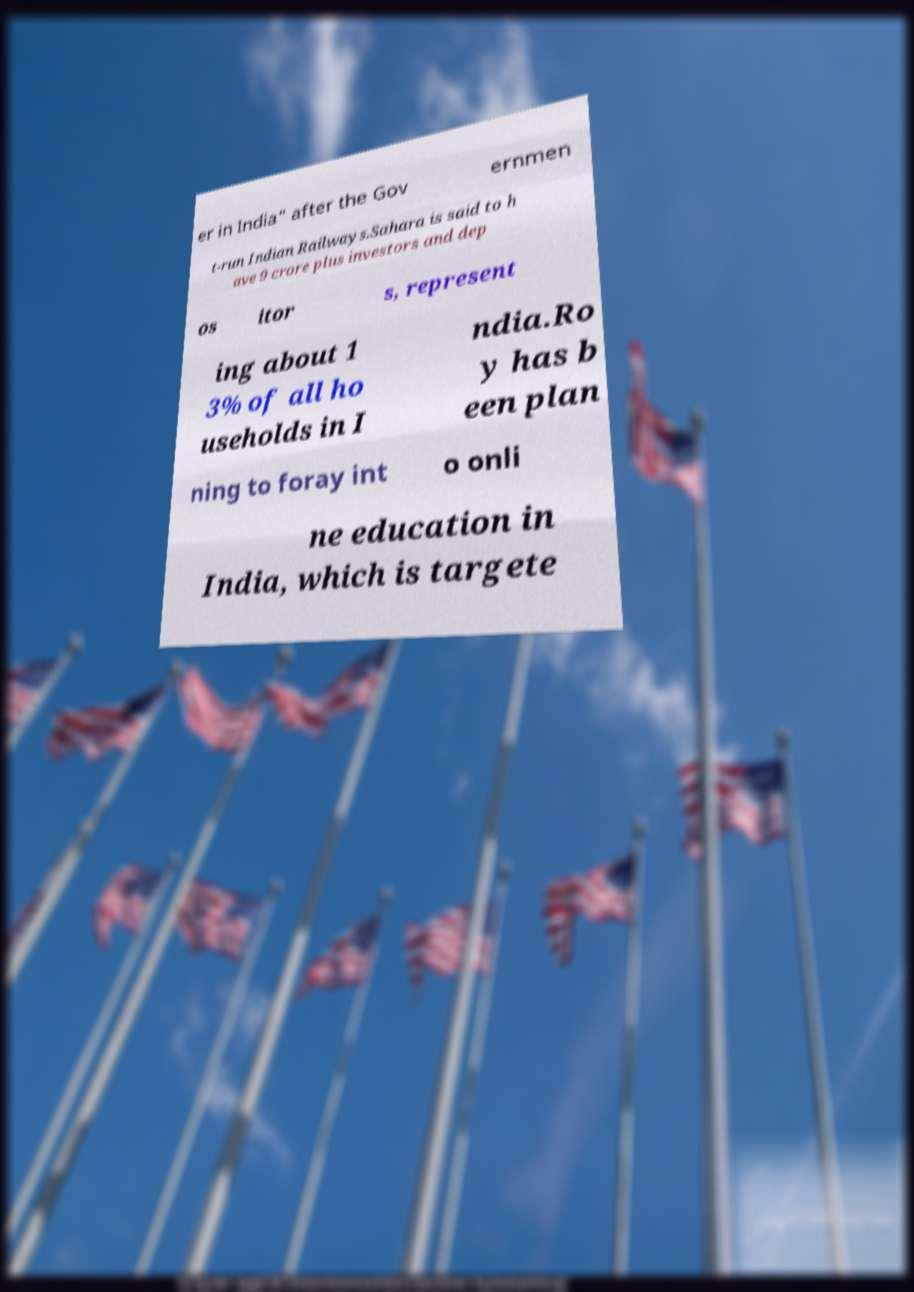Could you assist in decoding the text presented in this image and type it out clearly? er in India" after the Gov ernmen t-run Indian Railways.Sahara is said to h ave 9 crore plus investors and dep os itor s, represent ing about 1 3% of all ho useholds in I ndia.Ro y has b een plan ning to foray int o onli ne education in India, which is targete 